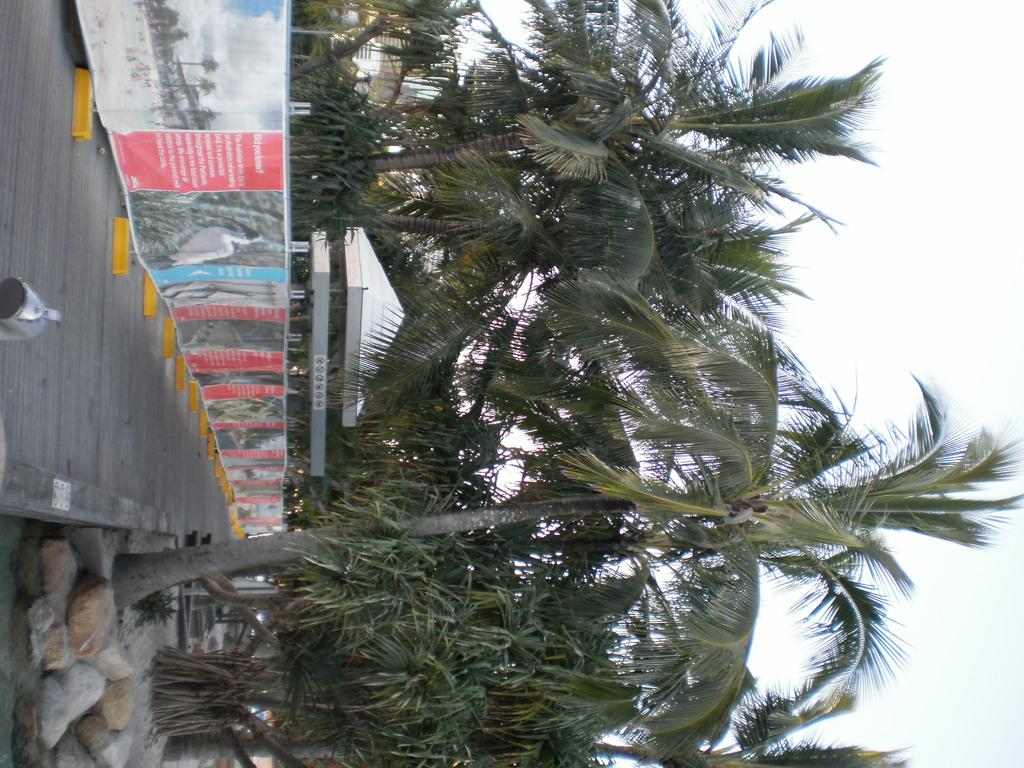What type of surface can be seen in the image? There is a walking path in the image. What else can be seen along the walking path? There are advertisements in the image. What natural elements are present in the image? Rocks and trees are present in the image. What type of terrain is visible in the image? Sand is visible in the image. What man-made structures are present in the image? There are buildings in the image. What is visible in the background of the image? The sky is visible in the image. What type of jewel is being displayed in the advertisement in the image? There is no advertisement for a jewel present in the image; the advertisements are not specified. What angle is the walking path at in the image? The angle of the walking path cannot be determined from the image alone, as it is a two-dimensional representation. 